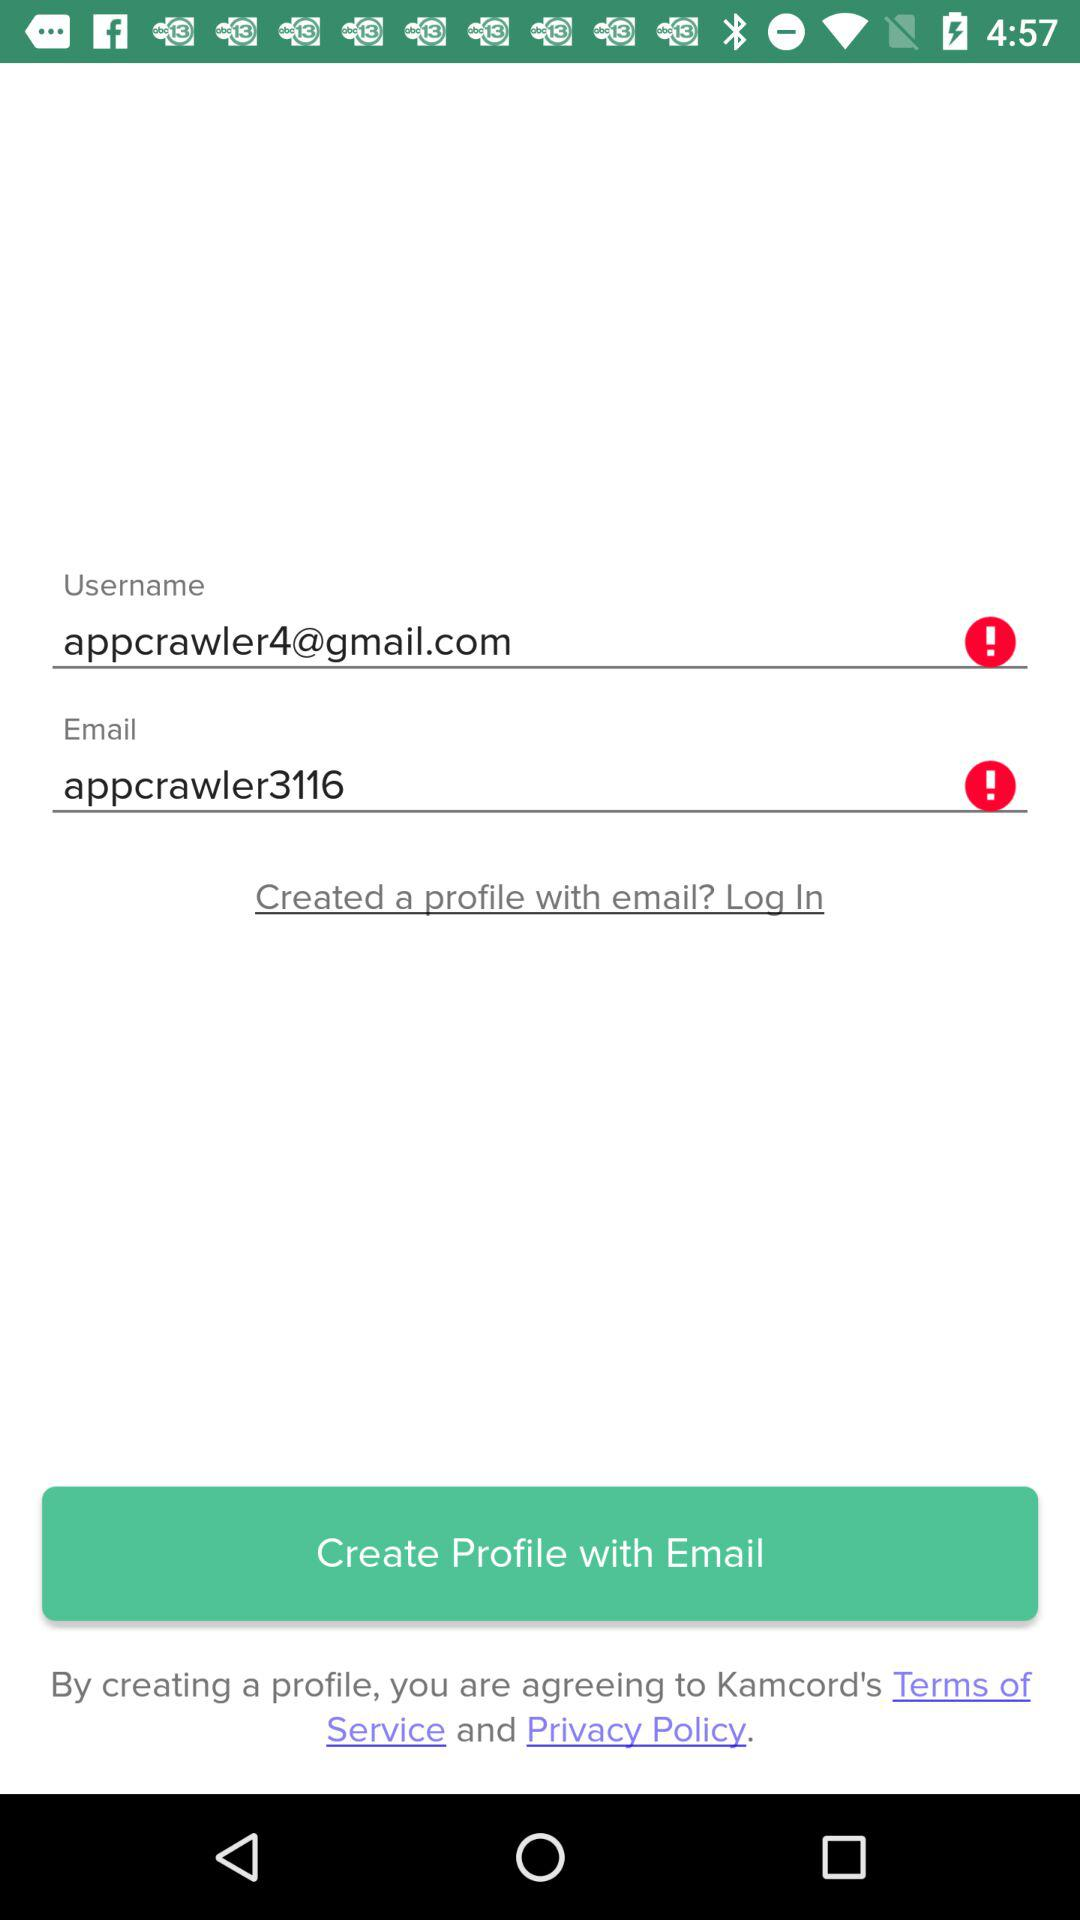What is the username? The username is "appcrawler3116". 